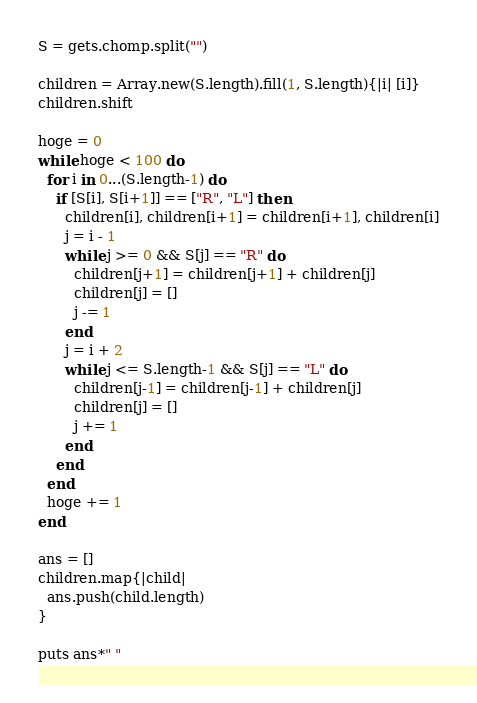Convert code to text. <code><loc_0><loc_0><loc_500><loc_500><_Ruby_>S = gets.chomp.split("")

children = Array.new(S.length).fill(1, S.length){|i| [i]}
children.shift

hoge = 0
while hoge < 100 do
  for i in 0...(S.length-1) do
    if [S[i], S[i+1]] == ["R", "L"] then
      children[i], children[i+1] = children[i+1], children[i]
      j = i - 1
      while j >= 0 && S[j] == "R" do
        children[j+1] = children[j+1] + children[j]
        children[j] = []
        j -= 1
      end
      j = i + 2
      while j <= S.length-1 && S[j] == "L" do
        children[j-1] = children[j-1] + children[j]
        children[j] = []
        j += 1
      end
    end
  end
  hoge += 1
end

ans = []
children.map{|child|
  ans.push(child.length)
}

puts ans*" "
</code> 